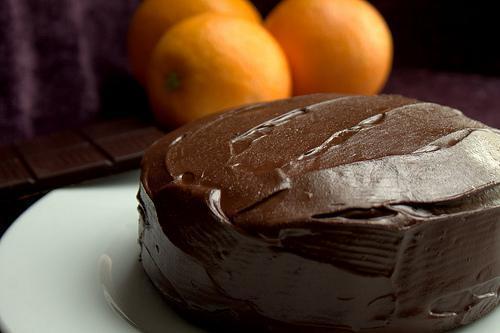How many oranges are in the picture?
Give a very brief answer. 3. How many cakes are in the picture?
Give a very brief answer. 1. 